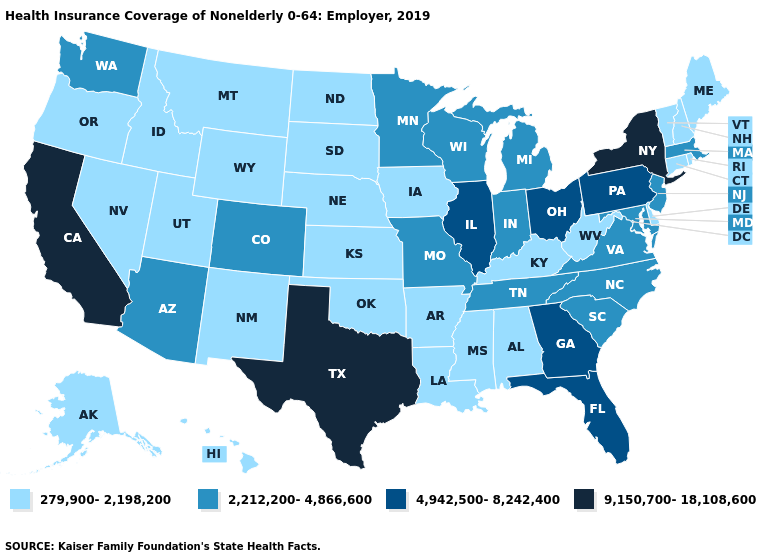Which states have the highest value in the USA?
Write a very short answer. California, New York, Texas. What is the value of Louisiana?
Be succinct. 279,900-2,198,200. Name the states that have a value in the range 279,900-2,198,200?
Quick response, please. Alabama, Alaska, Arkansas, Connecticut, Delaware, Hawaii, Idaho, Iowa, Kansas, Kentucky, Louisiana, Maine, Mississippi, Montana, Nebraska, Nevada, New Hampshire, New Mexico, North Dakota, Oklahoma, Oregon, Rhode Island, South Dakota, Utah, Vermont, West Virginia, Wyoming. Does Hawaii have the lowest value in the USA?
Give a very brief answer. Yes. What is the lowest value in the USA?
Concise answer only. 279,900-2,198,200. What is the value of New Hampshire?
Concise answer only. 279,900-2,198,200. What is the value of Minnesota?
Quick response, please. 2,212,200-4,866,600. Name the states that have a value in the range 2,212,200-4,866,600?
Keep it brief. Arizona, Colorado, Indiana, Maryland, Massachusetts, Michigan, Minnesota, Missouri, New Jersey, North Carolina, South Carolina, Tennessee, Virginia, Washington, Wisconsin. Name the states that have a value in the range 279,900-2,198,200?
Answer briefly. Alabama, Alaska, Arkansas, Connecticut, Delaware, Hawaii, Idaho, Iowa, Kansas, Kentucky, Louisiana, Maine, Mississippi, Montana, Nebraska, Nevada, New Hampshire, New Mexico, North Dakota, Oklahoma, Oregon, Rhode Island, South Dakota, Utah, Vermont, West Virginia, Wyoming. What is the value of Massachusetts?
Answer briefly. 2,212,200-4,866,600. Does Nebraska have a lower value than Ohio?
Give a very brief answer. Yes. Name the states that have a value in the range 4,942,500-8,242,400?
Concise answer only. Florida, Georgia, Illinois, Ohio, Pennsylvania. What is the value of New Jersey?
Short answer required. 2,212,200-4,866,600. Which states have the lowest value in the USA?
Give a very brief answer. Alabama, Alaska, Arkansas, Connecticut, Delaware, Hawaii, Idaho, Iowa, Kansas, Kentucky, Louisiana, Maine, Mississippi, Montana, Nebraska, Nevada, New Hampshire, New Mexico, North Dakota, Oklahoma, Oregon, Rhode Island, South Dakota, Utah, Vermont, West Virginia, Wyoming. What is the value of Colorado?
Quick response, please. 2,212,200-4,866,600. 